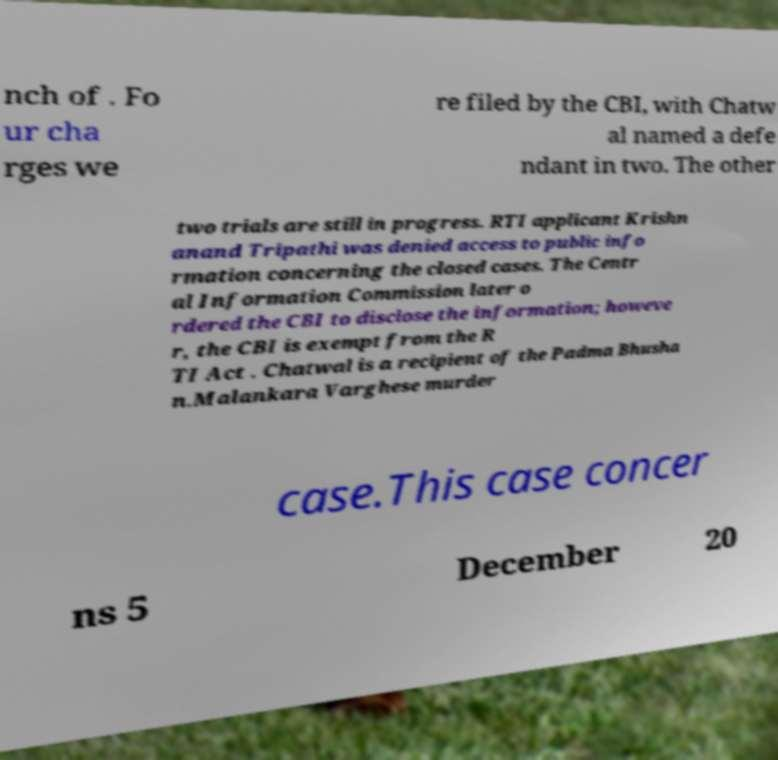Could you assist in decoding the text presented in this image and type it out clearly? nch of . Fo ur cha rges we re filed by the CBI, with Chatw al named a defe ndant in two. The other two trials are still in progress. RTI applicant Krishn anand Tripathi was denied access to public info rmation concerning the closed cases. The Centr al Information Commission later o rdered the CBI to disclose the information; howeve r, the CBI is exempt from the R TI Act . Chatwal is a recipient of the Padma Bhusha n.Malankara Varghese murder case.This case concer ns 5 December 20 